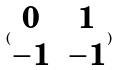<formula> <loc_0><loc_0><loc_500><loc_500>( \begin{matrix} 0 & 1 \\ - 1 & - 1 \end{matrix} )</formula> 